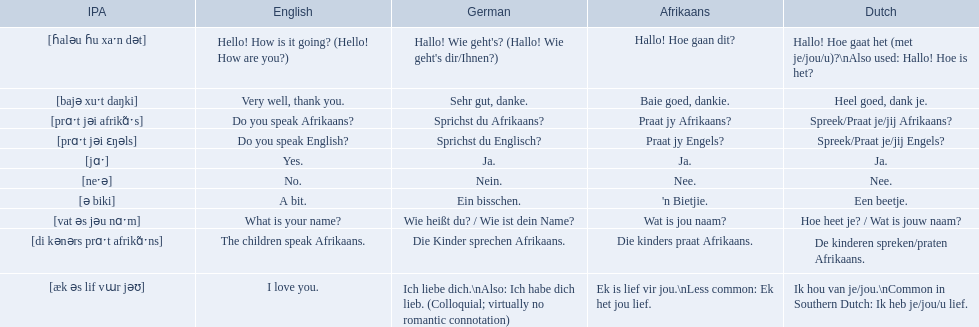What are the afrikaans phrases? Hallo! Hoe gaan dit?, Baie goed, dankie., Praat jy Afrikaans?, Praat jy Engels?, Ja., Nee., 'n Bietjie., Wat is jou naam?, Die kinders praat Afrikaans., Ek is lief vir jou.\nLess common: Ek het jou lief. For die kinders praat afrikaans, what are the translations? De kinderen spreken/praten Afrikaans., The children speak Afrikaans., Die Kinder sprechen Afrikaans. Which one is the german translation? Die Kinder sprechen Afrikaans. 